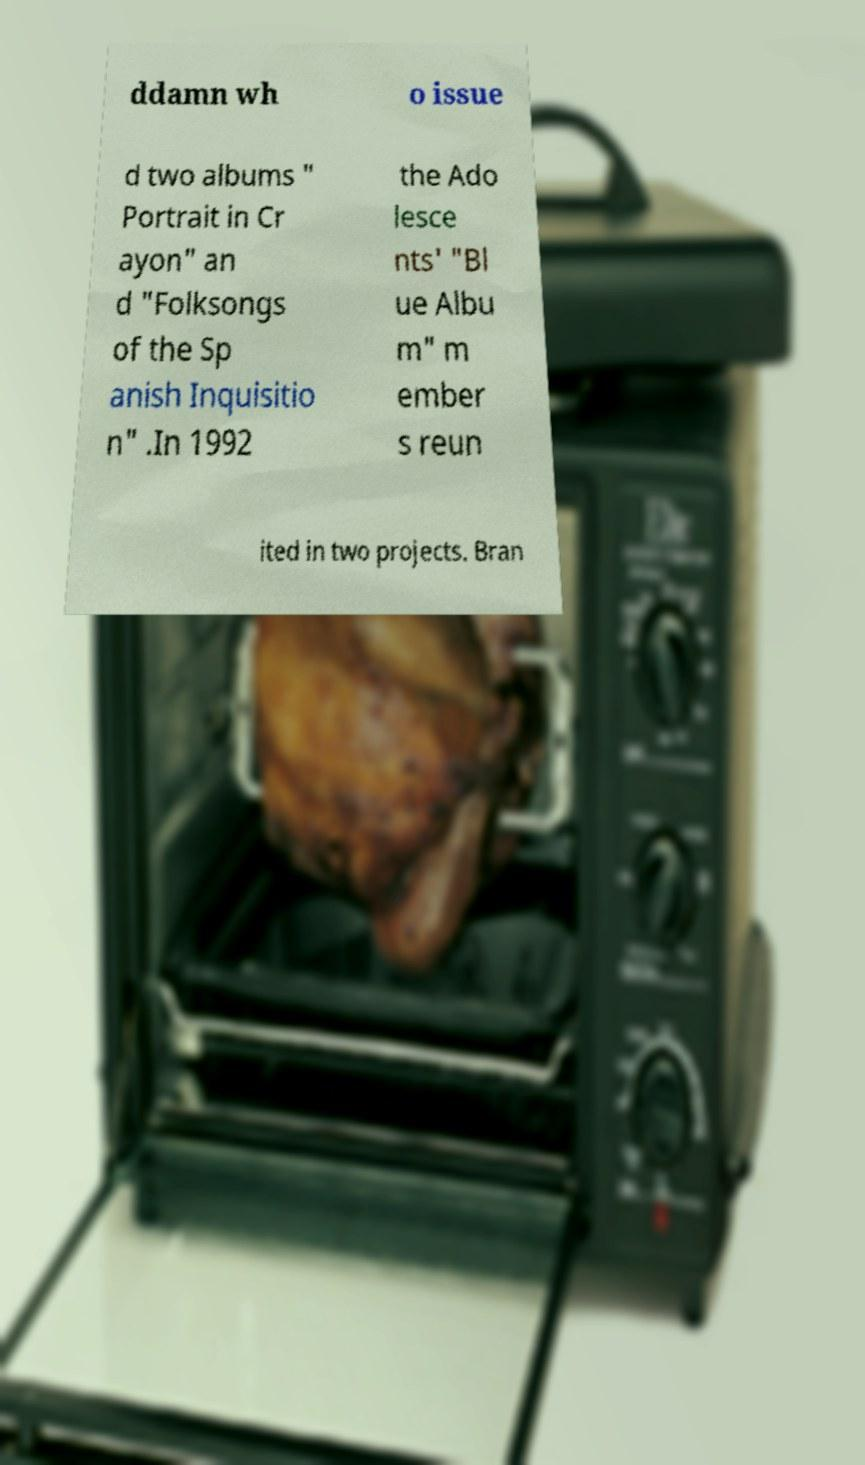Could you assist in decoding the text presented in this image and type it out clearly? ddamn wh o issue d two albums " Portrait in Cr ayon" an d "Folksongs of the Sp anish Inquisitio n" .In 1992 the Ado lesce nts' "Bl ue Albu m" m ember s reun ited in two projects. Bran 